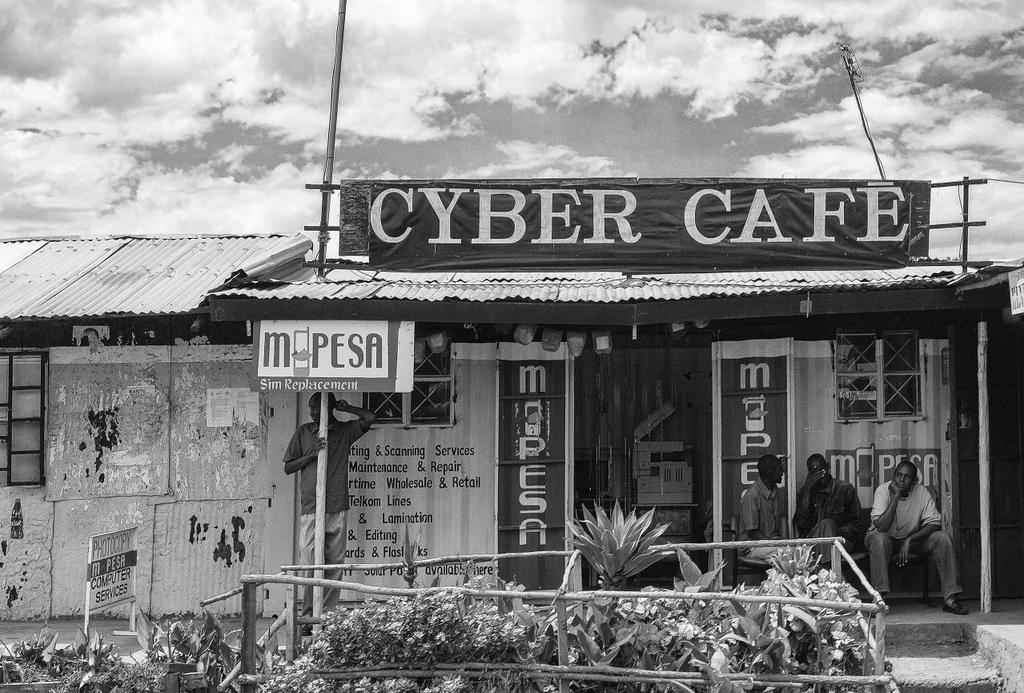<image>
Relay a brief, clear account of the picture shown. a black and white of store front Cyber Cafe 